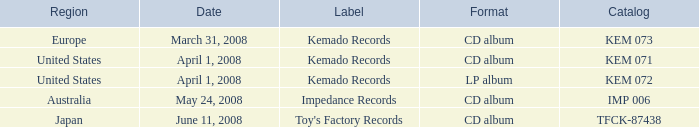Can you parse all the data within this table? {'header': ['Region', 'Date', 'Label', 'Format', 'Catalog'], 'rows': [['Europe', 'March 31, 2008', 'Kemado Records', 'CD album', 'KEM 073'], ['United States', 'April 1, 2008', 'Kemado Records', 'CD album', 'KEM 071'], ['United States', 'April 1, 2008', 'Kemado Records', 'LP album', 'KEM 072'], ['Australia', 'May 24, 2008', 'Impedance Records', 'CD album', 'IMP 006'], ['Japan', 'June 11, 2008', "Toy's Factory Records", 'CD album', 'TFCK-87438']]} What format includes a united states region and a kem 072 catalog? LP album. 